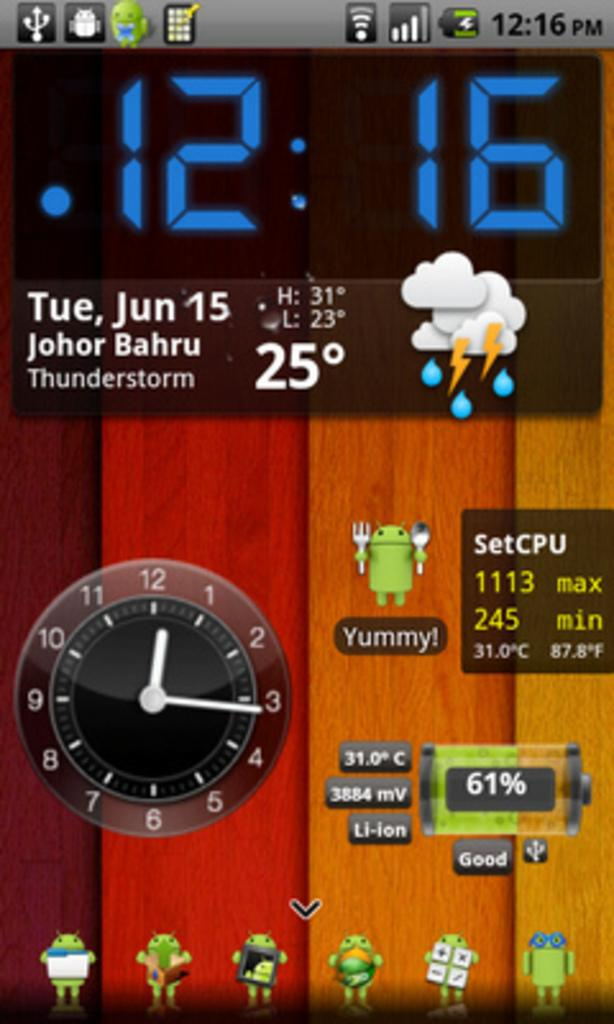<image>
Create a compact narrative representing the image presented. A screenshot from an Android phone showing the date as June 15th. 